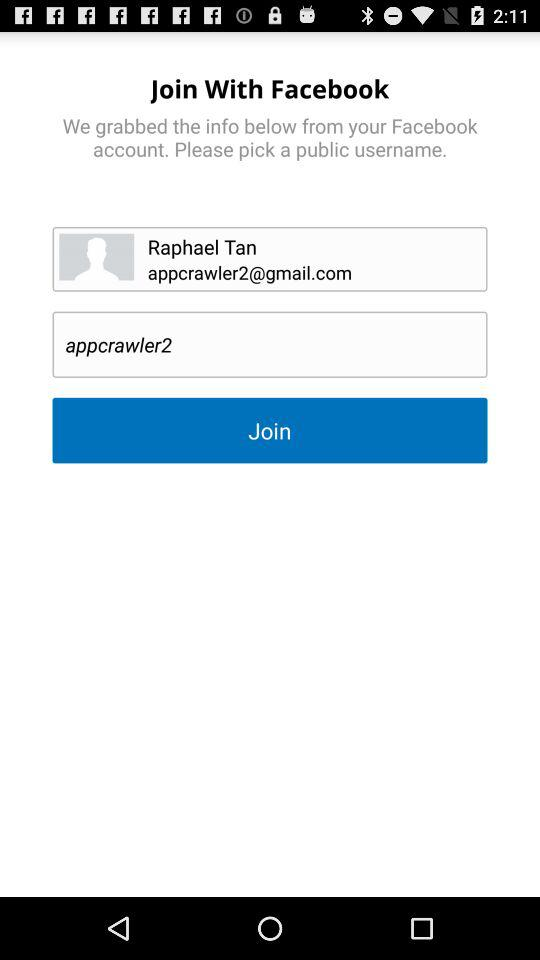What is the version of this application?
When the provided information is insufficient, respond with <no answer>. <no answer> 